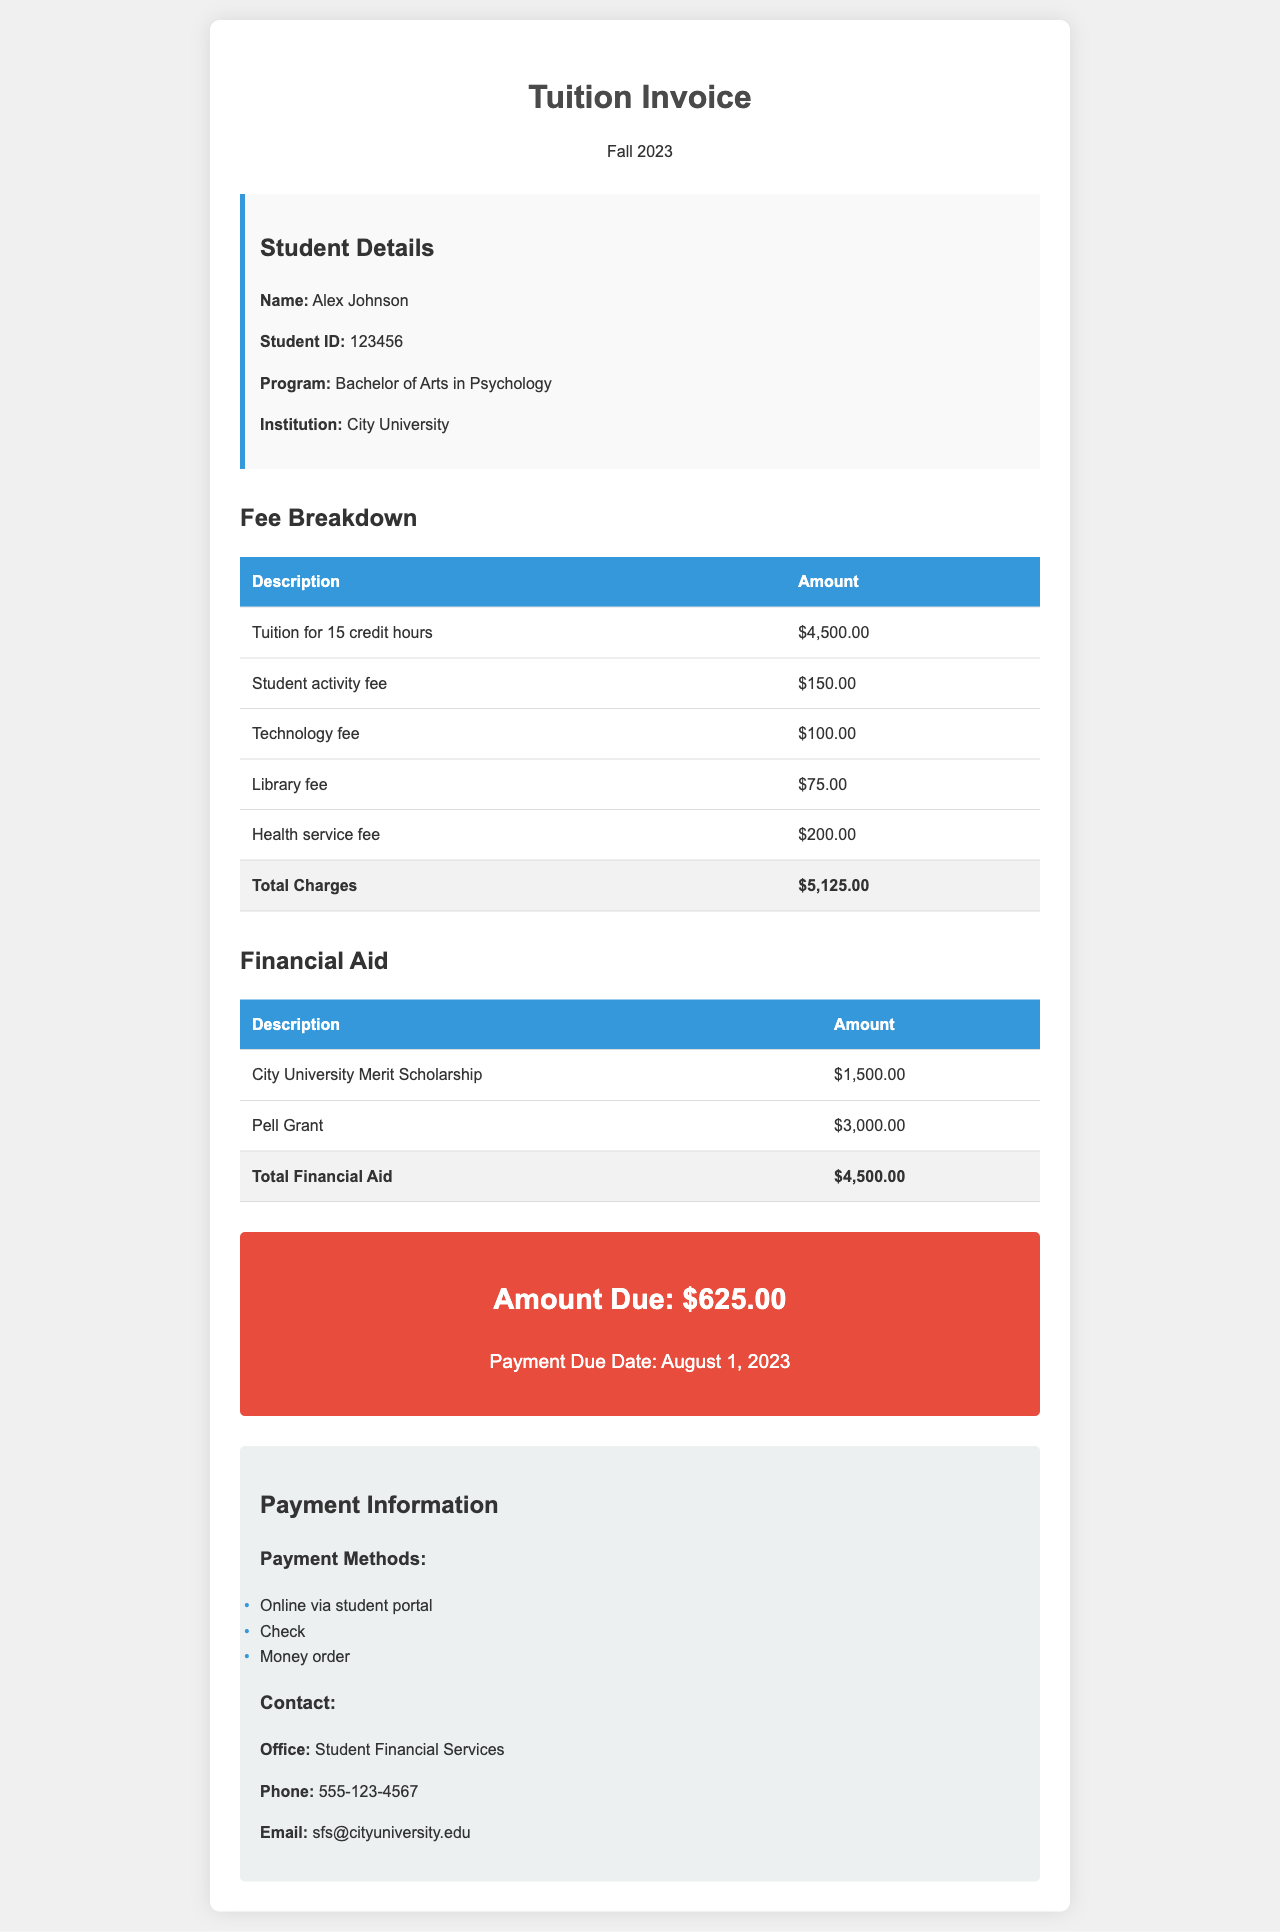what is the total amount due? The total amount due is displayed at the end of the invoice, which is clearly stated.
Answer: $625.00 who is the student? The student's name is mentioned in the student section of the invoice.
Answer: Alex Johnson what is the program of study? The program of study is specified in the student details section.
Answer: Bachelor of Arts in Psychology what is the health service fee? The health service fee is one of the fees listed in the fee breakdown table.
Answer: $200.00 how much is the Pell Grant? The Pell Grant amount is listed under the financial aid section of the invoice.
Answer: $3,000.00 what date is the payment due? The payment due date is mentioned in the amount due section of the invoice.
Answer: August 1, 2023 how much total financial aid is provided? The total financial aid amount is given at the bottom of the financial aid table.
Answer: $4,500.00 what is the institution's name? The institution's name is displayed in the student information section of the invoice.
Answer: City University what fees are included in the total charges? The total charges include tuition and various fees detailed in the fee breakdown table.
Answer: Tuition for 15 credit hours, student activity fee, technology fee, library fee, health service fee 